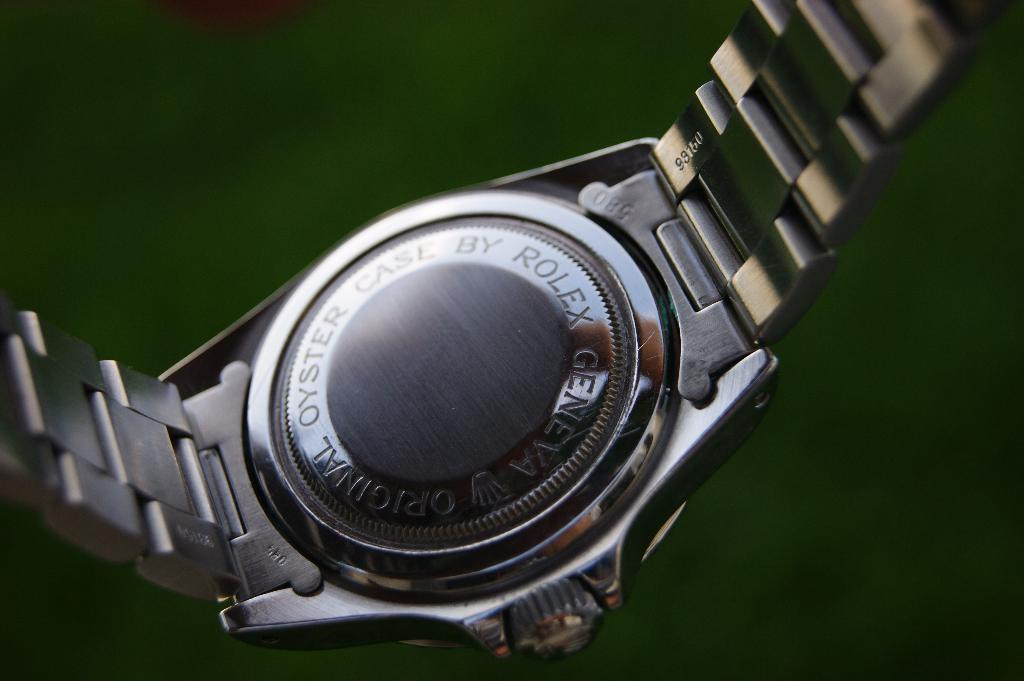<image>
Give a short and clear explanation of the subsequent image. The back of a silver colored watch by Rolex. 